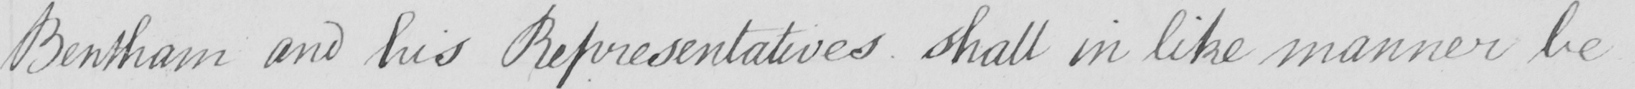Can you tell me what this handwritten text says? Bentham and his Representatives shall in like manner be 